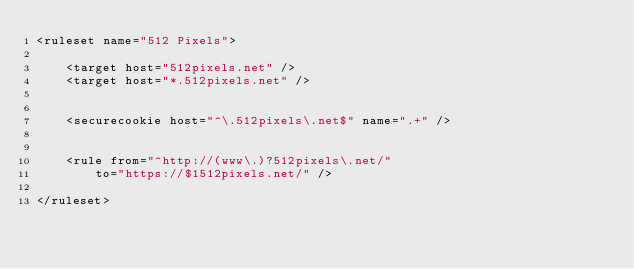Convert code to text. <code><loc_0><loc_0><loc_500><loc_500><_XML_><ruleset name="512 Pixels">

	<target host="512pixels.net" />
	<target host="*.512pixels.net" />


	<securecookie host="^\.512pixels\.net$" name=".+" />


	<rule from="^http://(www\.)?512pixels\.net/"
		to="https://$1512pixels.net/" />

</ruleset></code> 